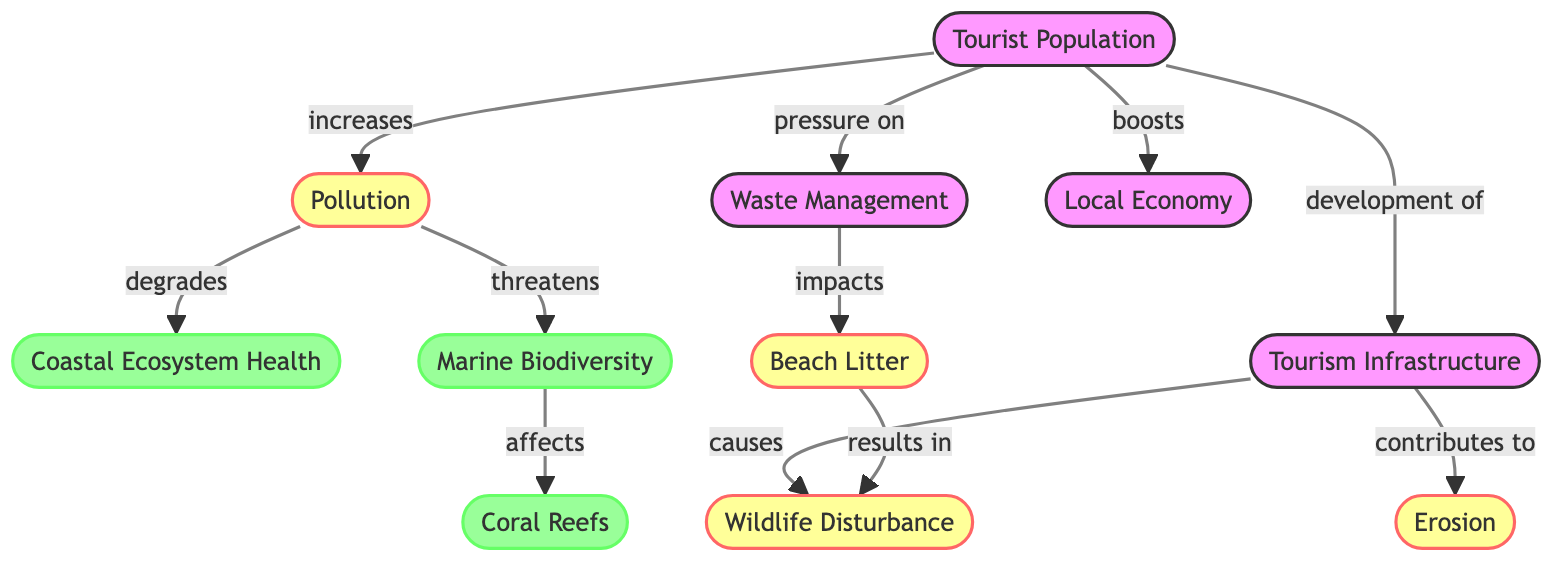What is the total number of nodes in the diagram? The diagram lists nodes such as Tourist Population, Coastal Ecosystem Health, Pollution, Marine Biodiversity, Waste Management, Local Economy, Erosion, Coral Reefs, Beach Litter, Tourism Infrastructure, and Wildlife Disturbance. Counting these, there are 11 distinct nodes.
Answer: 11 What relationship does Pollution have with Marine Biodiversity? The diagram shows that Pollution "threatens" Marine Biodiversity, indicating a negative impact or consequence. This connection is direct and states the relationship clearly.
Answer: threatens What node is impacted by Waste Management? The diagram indicates that Waste Management "impacts" Beach Litter. This reveals the nature of the relationship, where poor waste management leads to beach litter accumulation.
Answer: Beach Litter How many edges are related to the Tourist Population? The edges related to Tourist Population include: it "increases" Pollution, it creates "pressure on" Waste Management, it "boosts" Local Economy, and it leads to "development of" Tourism Infrastructure. This sums up to 4 edges directly related to the Tourist Population.
Answer: 4 What role does Tourism Infrastructure play in relation to Erosion? The diagram specifies that Tourism Infrastructure "contributes to" Erosion, indicating that the development and construction related to tourism may lead to coastal erosion effects.
Answer: contributes to Which node directly affects Coral Reefs? The diagram highlights that Marine Biodiversity "affects" Coral Reefs. This relationship identifies that the health of marine life plays a crucial role in the condition of coral ecosystems.
Answer: Marine Biodiversity What is the impact of Beach Litter on Wildlife Disturbance? The diagram states that Beach Litter "results in" Wildlife Disturbance, showing a consequence where litter on beaches can lead to disturbances in local wildlife activities or habitats.
Answer: results in How does Pollution affect Coastal Ecosystem Health? The diagram indicates that Pollution "degrades" Coastal Ecosystem Health. This shows a direct negative relationship, where pollution contributes to the deterioration of the health of coastal ecosystems.
Answer: degrades What is the link between Tourist Population and Local Economy? The diagram illustrates that Tourist Population "boosts" Local Economy. This establishes a positive relationship where an increase in tourism contributes to the economic growth of the local area.
Answer: boosts 